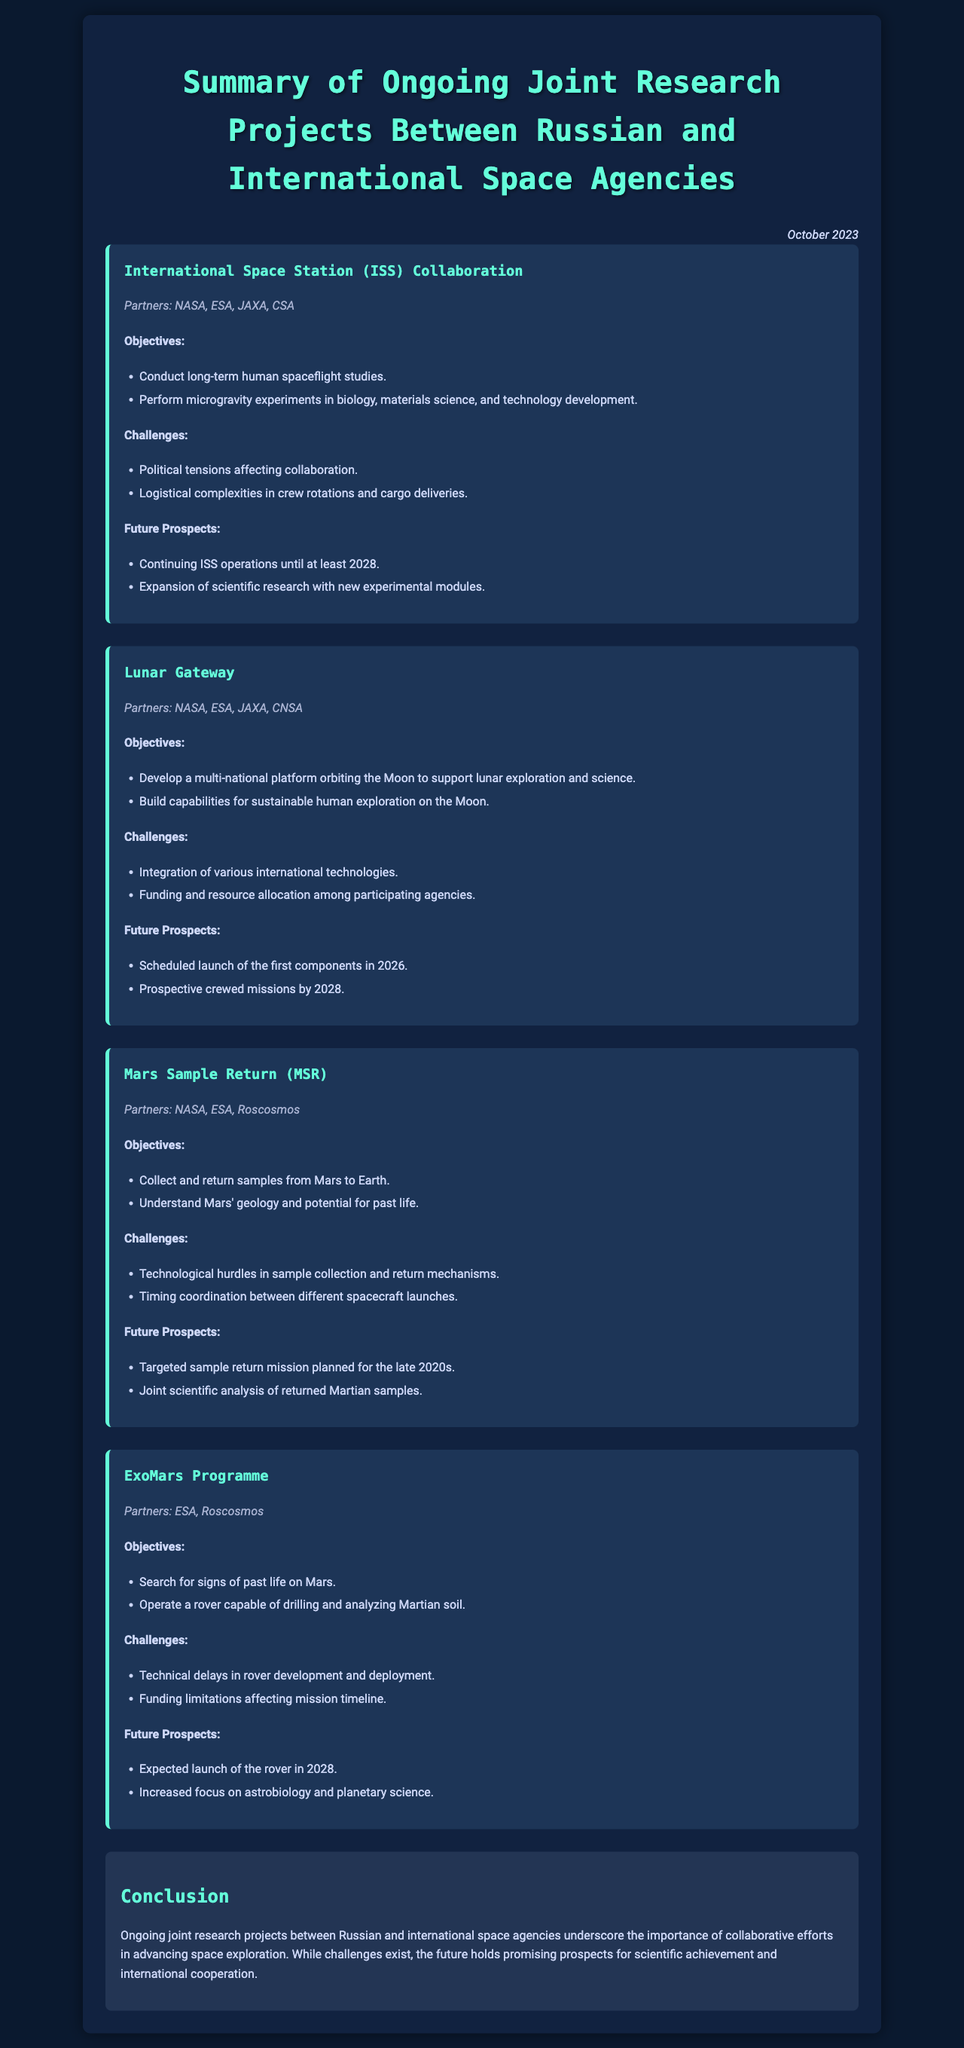What are the main partners of the ISS collaboration? The partners involved in the ISS collaboration are listed directly in the document under the project section.
Answer: NASA, ESA, JAXA, CSA What is the targeted launch year for the ExoMars rover? The document specifies the expected launch year for the ExoMars rover in the future prospects section.
Answer: 2028 What is one of the key objectives of the Mars Sample Return project? The objectives for the Mars Sample Return project are outlined and one can be directly quoted from the document.
Answer: Collect and return samples from Mars to Earth What challenges are faced in the Lunar Gateway project? The document outlines specific challenges under the challenges section of the Lunar Gateway project.
Answer: Integration of various international technologies What is the conclusion regarding future prospects of joint research projects? The conclusion summarizes the overall outlook for joint research projects based on collaborative efforts noted in the document.
Answer: Promising prospects for scientific achievement and international cooperation 